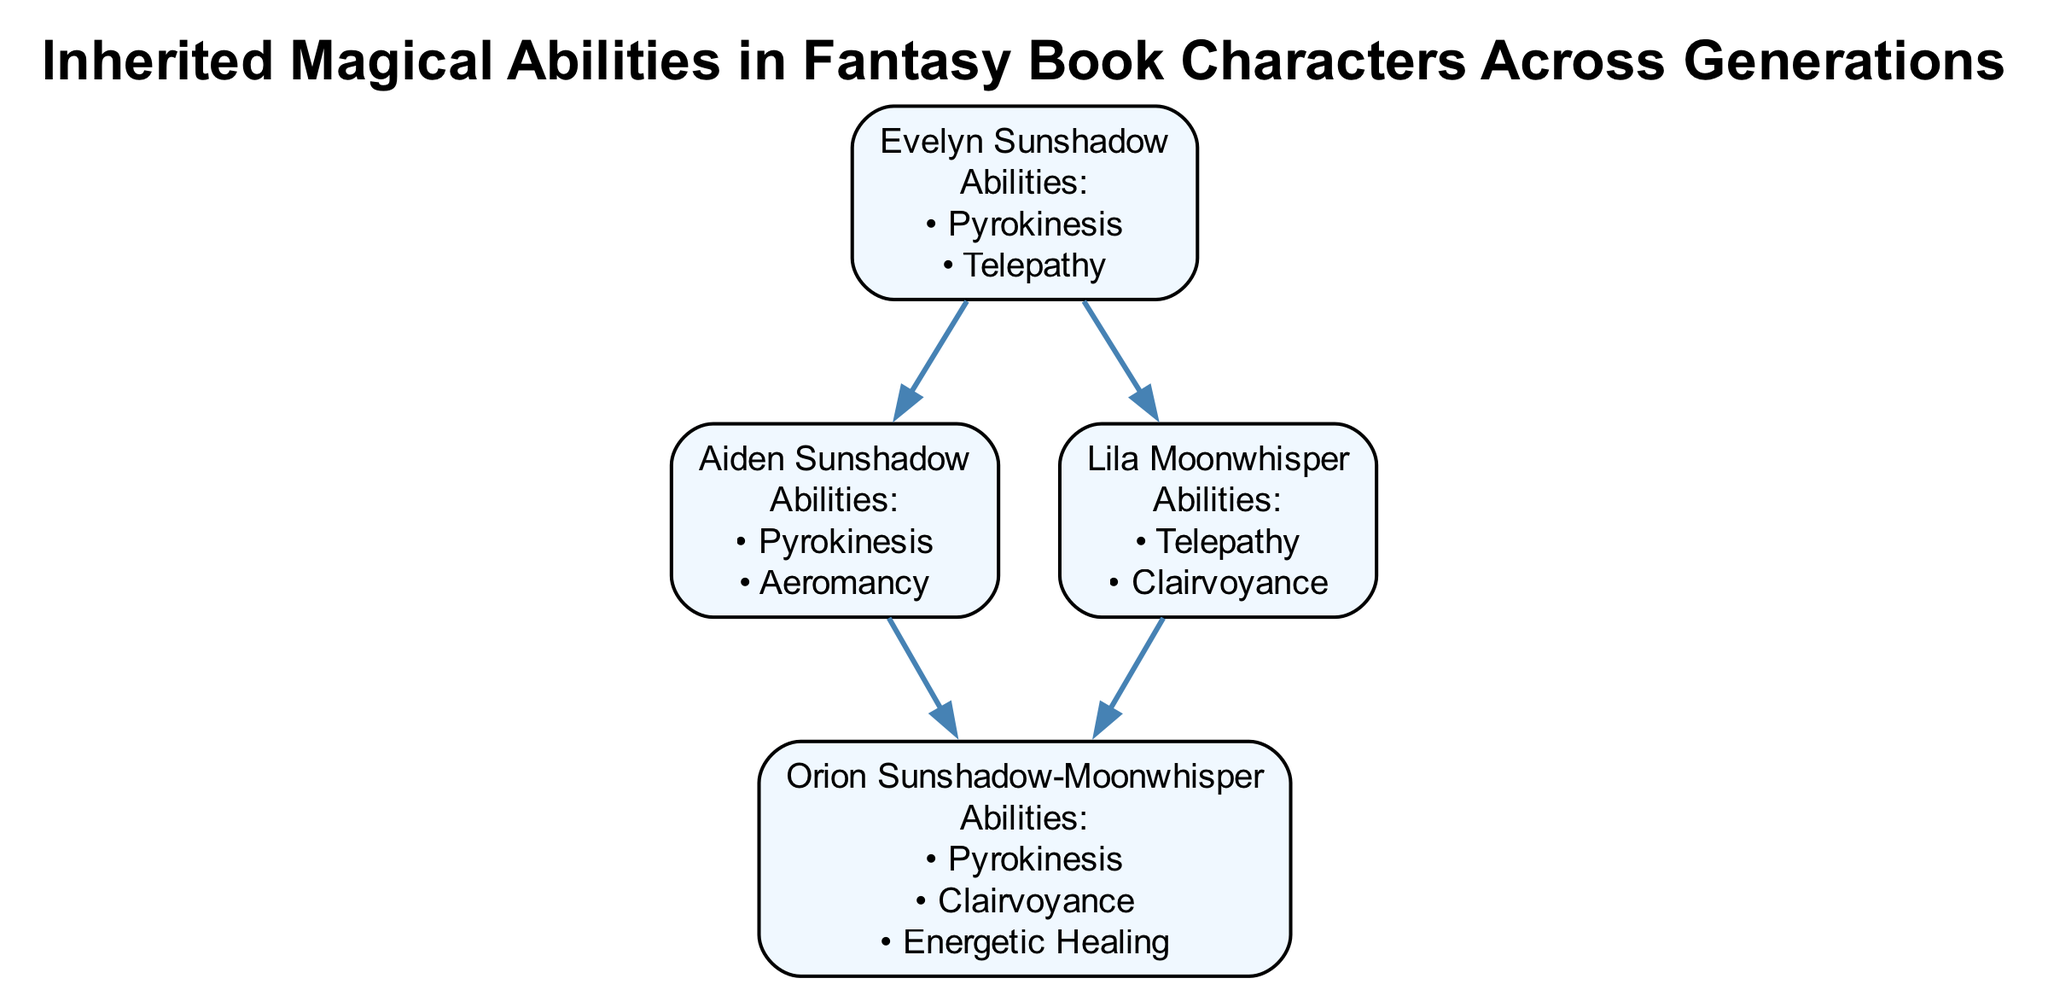What abilities does Orion Sunshadow-Moonwhisper inherit from his parents? Orion Sunshadow-Moonwhisper inherits Pyrokinesis from Aiden and Evelyn, and Clairvoyance from Lila. He also possesses Energetic Healing, which is unique to him but does not come from his parents.
Answer: Pyrokinesis, Clairvoyance, Energetic Healing How many characters are in the first generation? The diagram displays one character in the first generation, which is Evelyn Sunshadow.
Answer: 1 Which ability is unique to Lila Moonwhisper? Lila Moonwhisper possesses Clairvoyance and Telepathy, but Clairvoyance is passed to Orion. Thus, Telepathy is unique to her in this diagram.
Answer: Telepathy What are the generations represented in the diagram? The diagram includes three generations: 1 (Evelyn), 2 (Aiden and Lila), and 3 (Orion).
Answer: 1, 2, 3 Who has inherited Pyrokinesis? Pyrokinesis is inherited by Aiden from Evelyn, and then by Orion from both Aiden and Evelyn.
Answer: Aiden, Orion How many abilities does Aiden Sunshadow have? Aiden Sunshadow has two abilities described in the diagram: Pyrokinesis and Aeromancy.
Answer: 2 What is the relationship between Orion and Lila? Orion is the child of Lila Moonwhisper, making her his mother.
Answer: Mother Which character possesses the ability of Energetic Healing? Energetic Healing is a unique ability possessed only by Orion Sunshadow-Moonwhisper in the diagram.
Answer: Orion Sunshadow-Moonwhisper How is Clairvoyance inherited in the family tree? Clairvoyance is inherited from Lila Moonwhisper to her child, Orion Sunshadow-Moonwhisper, creating a lineage connection between them.
Answer: From Lila to Orion 